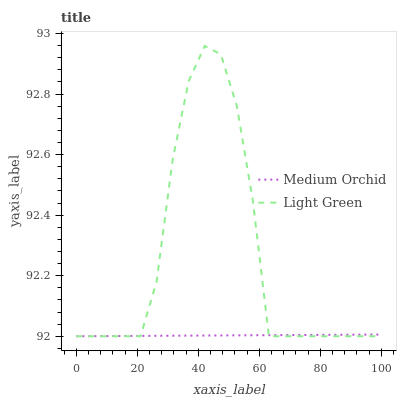Does Light Green have the minimum area under the curve?
Answer yes or no. No. Is Light Green the smoothest?
Answer yes or no. No. 